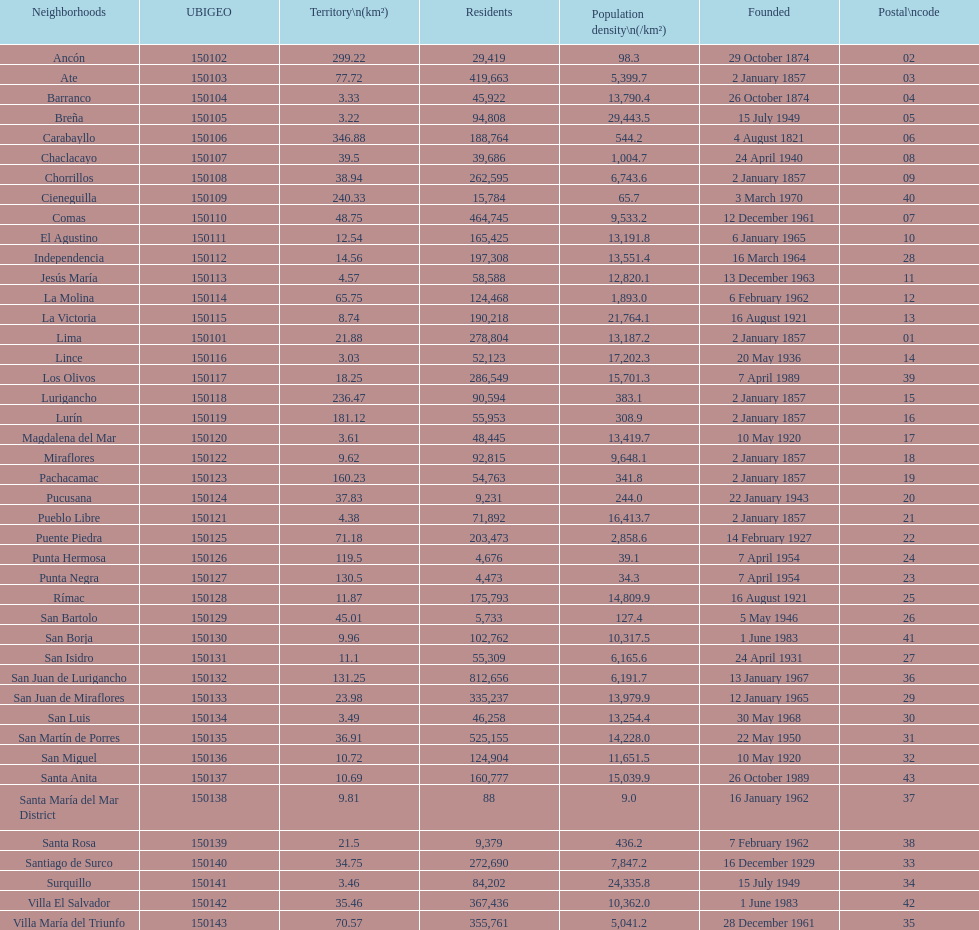Which district in this city has the greatest population? San Juan de Lurigancho. 